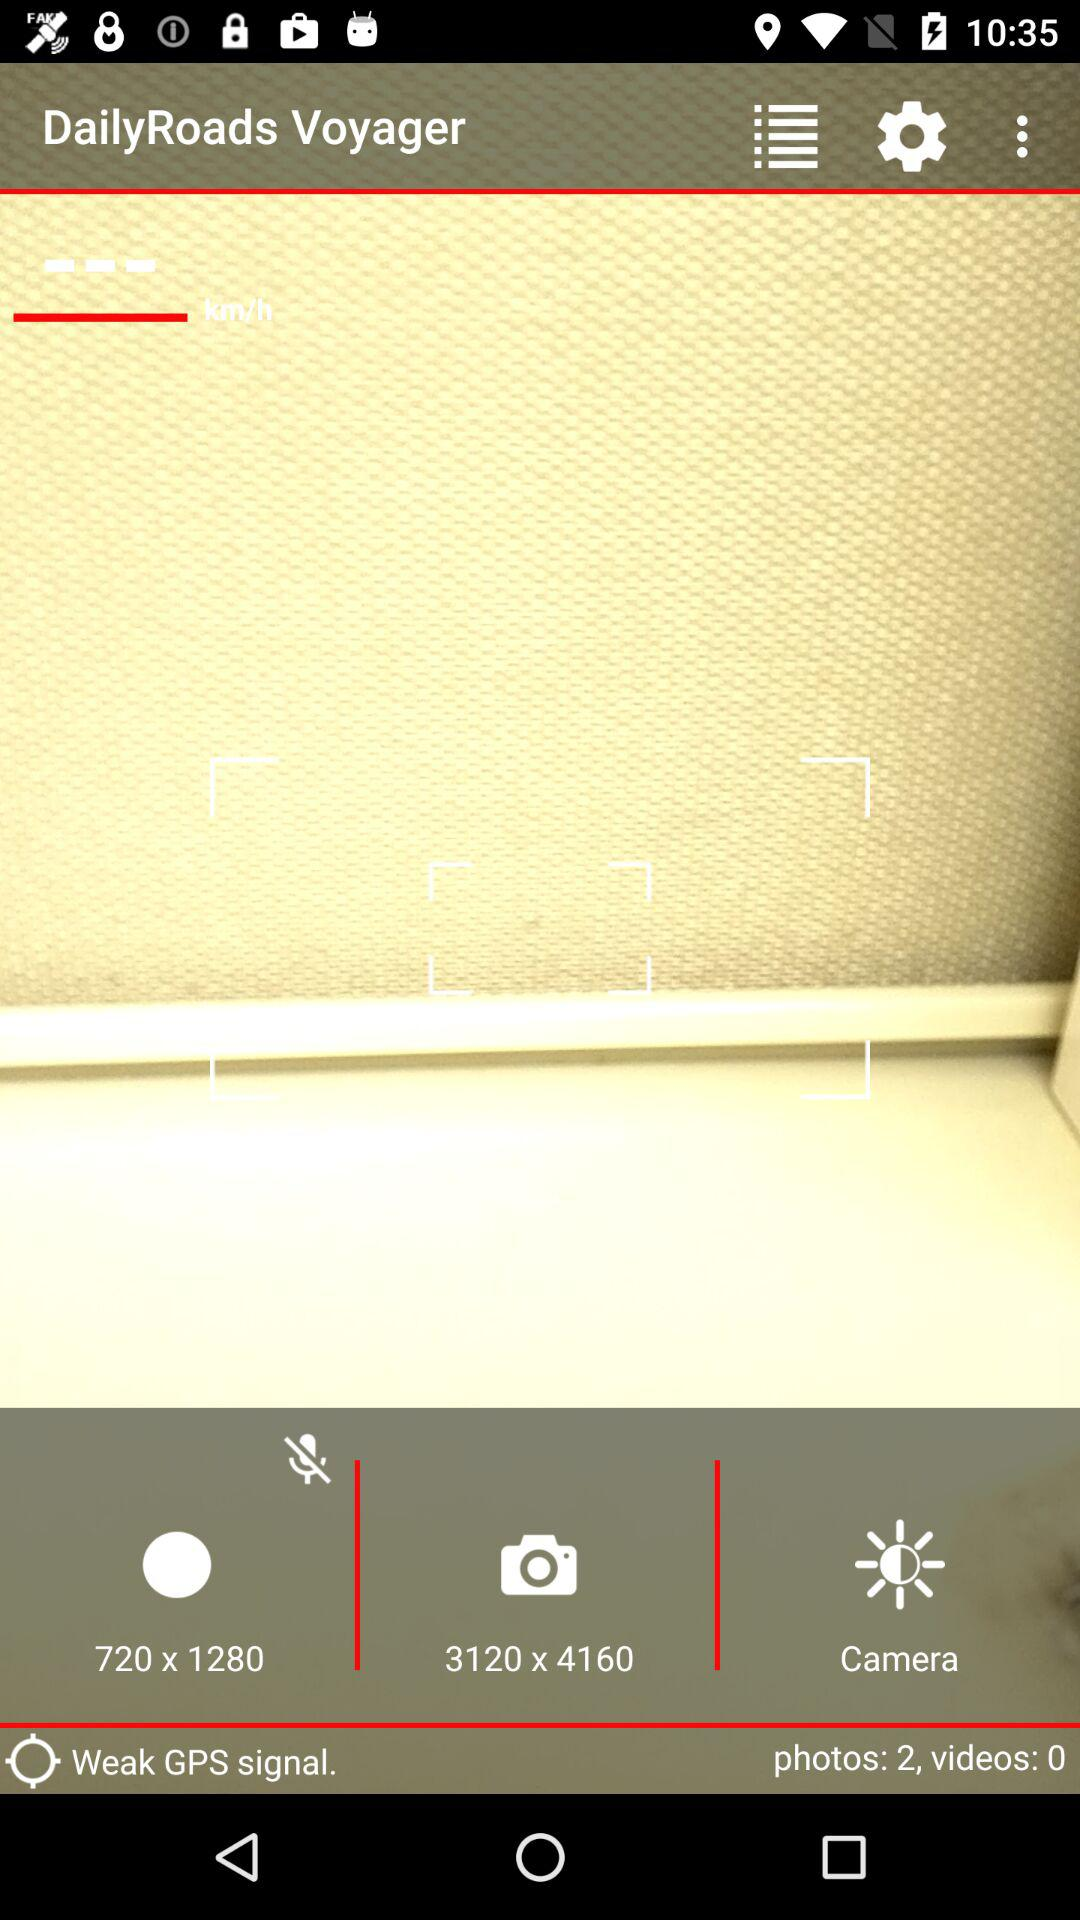What is the GPS signal strength? The GPS signal strength is "Weak". 